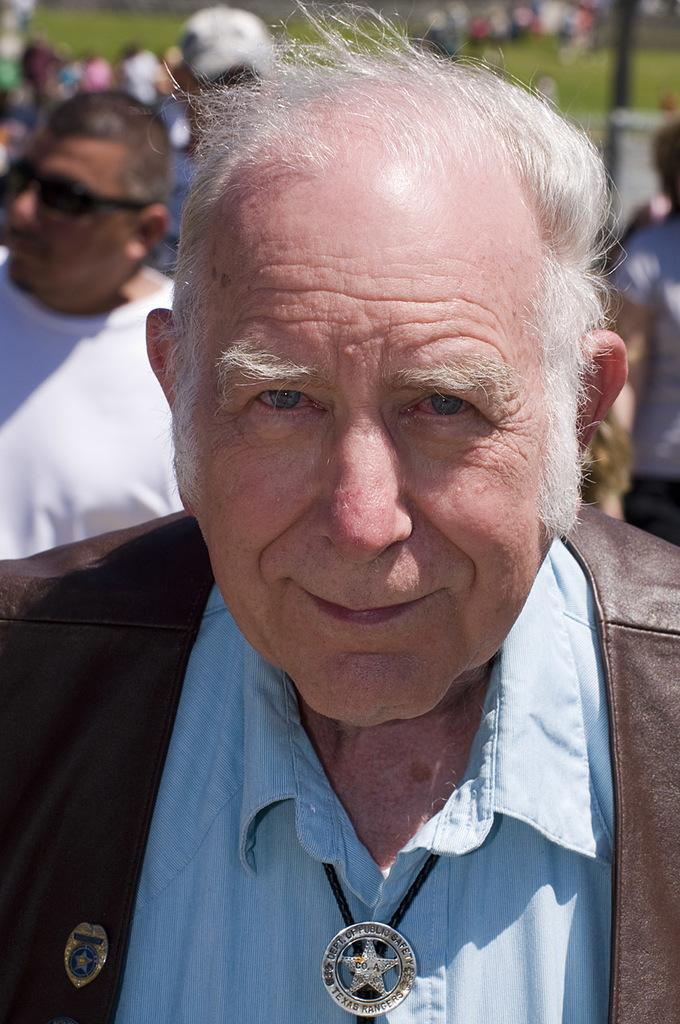What is the main subject of the image? There is a person in the image. Can you describe the setting in which the person is located? There is grass visible in the image. Are there any other people present in the image? Yes, there is a group of people in the background of the image. What type of pie can be seen in the hands of the person in the image? There is no pie present in the image; the person is not holding any food item. How many deer are visible in the image? There are no deer present in the image. 